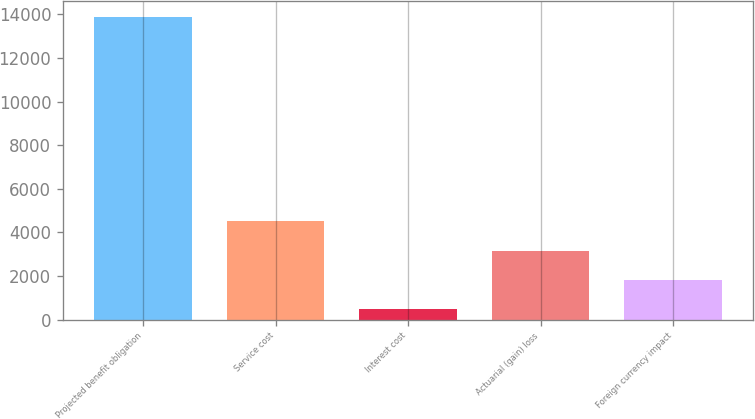<chart> <loc_0><loc_0><loc_500><loc_500><bar_chart><fcel>Projected benefit obligation<fcel>Service cost<fcel>Interest cost<fcel>Actuarial (gain) loss<fcel>Foreign currency impact<nl><fcel>13900<fcel>4499.7<fcel>471<fcel>3156.8<fcel>1813.9<nl></chart> 